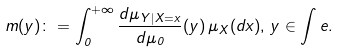Convert formula to latex. <formula><loc_0><loc_0><loc_500><loc_500>m ( y ) \colon = \int _ { 0 } ^ { + \infty } \frac { d \mu _ { Y | X = x } } { d \mu _ { 0 } } ( y ) \, \mu _ { X } ( d x ) , \, y \in \int e .</formula> 